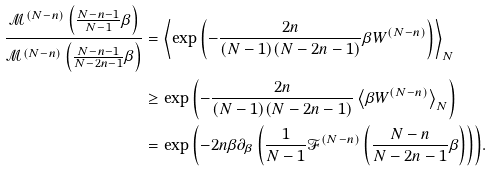<formula> <loc_0><loc_0><loc_500><loc_500>\frac { \mathcal { M } ^ { ( N - n ) } \left ( \frac { N - n - 1 } { N - 1 } \beta \right ) } { \mathcal { M } ^ { ( N - n ) } \left ( \frac { N - n - 1 } { N - 2 n - 1 } \beta \right ) } & = \left \langle \exp { \left ( - \frac { 2 n } { ( N - 1 ) ( N - 2 n - 1 ) } \beta W ^ { ( N - n ) } \right ) } \right \rangle _ { N } \\ & \geq \exp { \left ( - \frac { 2 n } { ( N - 1 ) ( N - 2 n - 1 ) } \left \langle \beta W ^ { ( N - n ) } \right \rangle _ { N } \right ) } \\ & = \exp { \left ( - 2 n \beta \partial _ { \beta } \left ( \frac { 1 } { N - 1 } \mathcal { F } ^ { ( N - n ) } \left ( \frac { N - n } { N - 2 n - 1 } \beta \right ) \right ) \right ) } .</formula> 